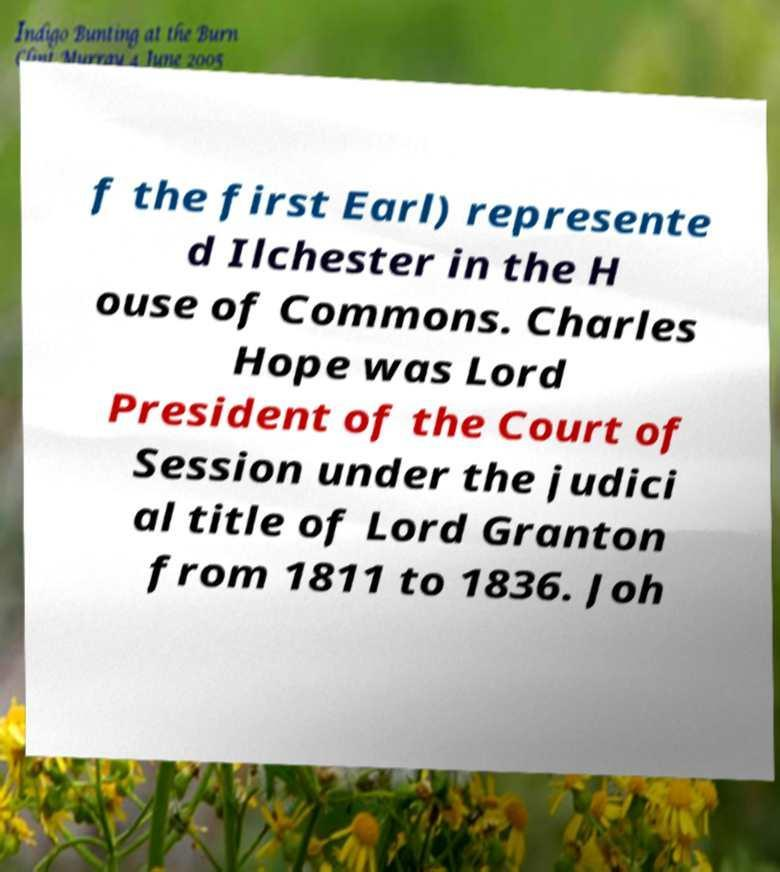Please identify and transcribe the text found in this image. f the first Earl) represente d Ilchester in the H ouse of Commons. Charles Hope was Lord President of the Court of Session under the judici al title of Lord Granton from 1811 to 1836. Joh 